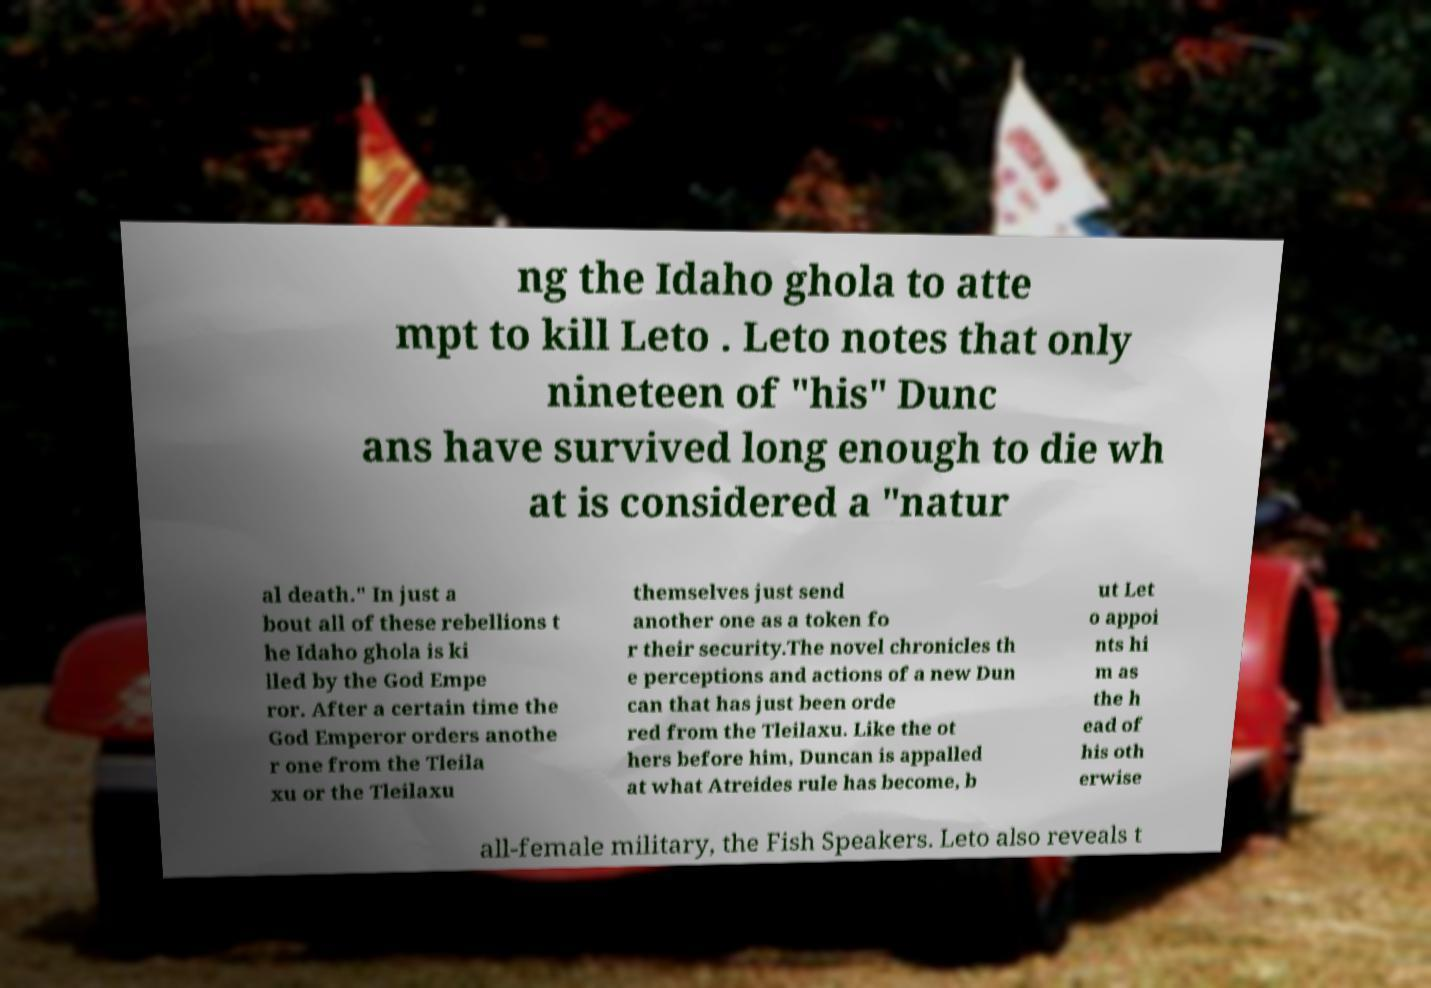Can you read and provide the text displayed in the image?This photo seems to have some interesting text. Can you extract and type it out for me? ng the Idaho ghola to atte mpt to kill Leto . Leto notes that only nineteen of "his" Dunc ans have survived long enough to die wh at is considered a "natur al death." In just a bout all of these rebellions t he Idaho ghola is ki lled by the God Empe ror. After a certain time the God Emperor orders anothe r one from the Tleila xu or the Tleilaxu themselves just send another one as a token fo r their security.The novel chronicles th e perceptions and actions of a new Dun can that has just been orde red from the Tleilaxu. Like the ot hers before him, Duncan is appalled at what Atreides rule has become, b ut Let o appoi nts hi m as the h ead of his oth erwise all-female military, the Fish Speakers. Leto also reveals t 